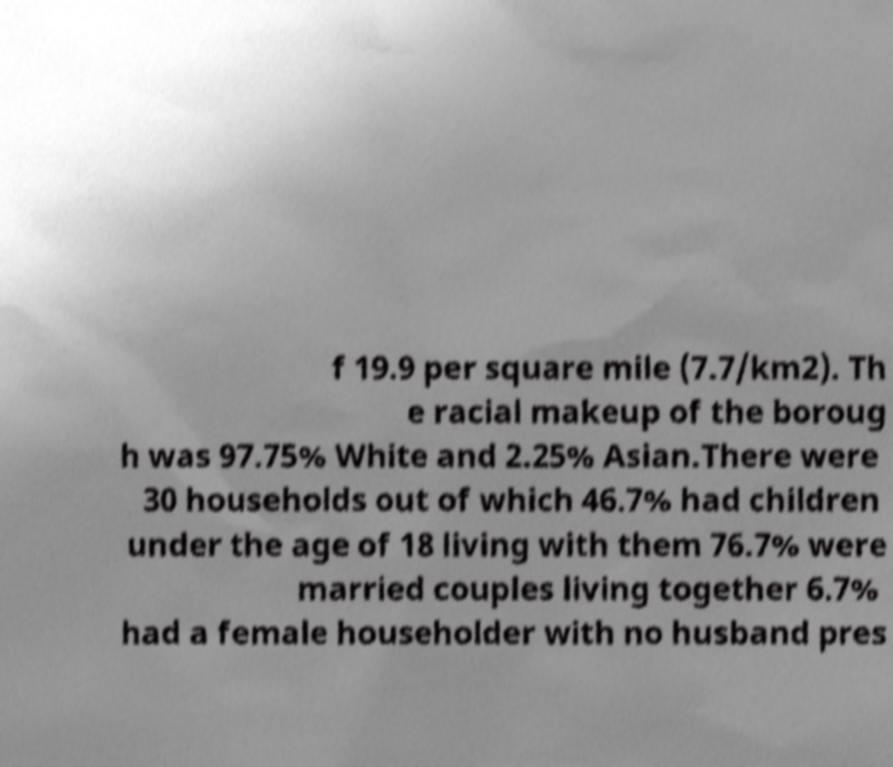Please read and relay the text visible in this image. What does it say? f 19.9 per square mile (7.7/km2). Th e racial makeup of the boroug h was 97.75% White and 2.25% Asian.There were 30 households out of which 46.7% had children under the age of 18 living with them 76.7% were married couples living together 6.7% had a female householder with no husband pres 